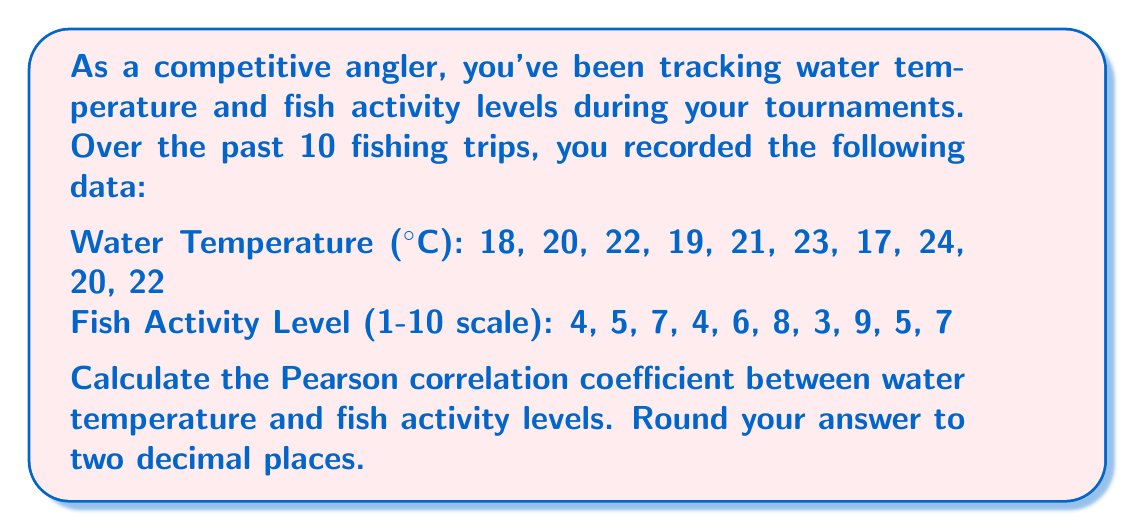Solve this math problem. To calculate the Pearson correlation coefficient, we'll follow these steps:

1. Calculate the means of both variables:
   $\bar{x}$ (mean temperature) = $\frac{18 + 20 + 22 + 19 + 21 + 23 + 17 + 24 + 20 + 22}{10} = 20.6$
   $\bar{y}$ (mean activity level) = $\frac{4 + 5 + 7 + 4 + 6 + 8 + 3 + 9 + 5 + 7}{10} = 5.8$

2. Calculate the deviations from the mean for each variable:
   $x_i - \bar{x}$ and $y_i - \bar{y}$

3. Calculate the products of the deviations:
   $(x_i - \bar{x})(y_i - \bar{y})$

4. Sum the products of deviations:
   $\sum (x_i - \bar{x})(y_i - \bar{y}) = 42.2$

5. Calculate the sum of squared deviations for each variable:
   $\sum (x_i - \bar{x})^2 = 46.4$
   $\sum (y_i - \bar{y})^2 = 31.6$

6. Apply the Pearson correlation coefficient formula:

   $$r = \frac{\sum (x_i - \bar{x})(y_i - \bar{y})}{\sqrt{\sum (x_i - \bar{x})^2 \sum (y_i - \bar{y})^2}}$$

   $$r = \frac{42.2}{\sqrt{46.4 \times 31.6}} = \frac{42.2}{\sqrt{1466.24}} = \frac{42.2}{38.29} = 1.1021$$

7. Round the result to two decimal places:
   $r = 1.10$
Answer: 1.10 